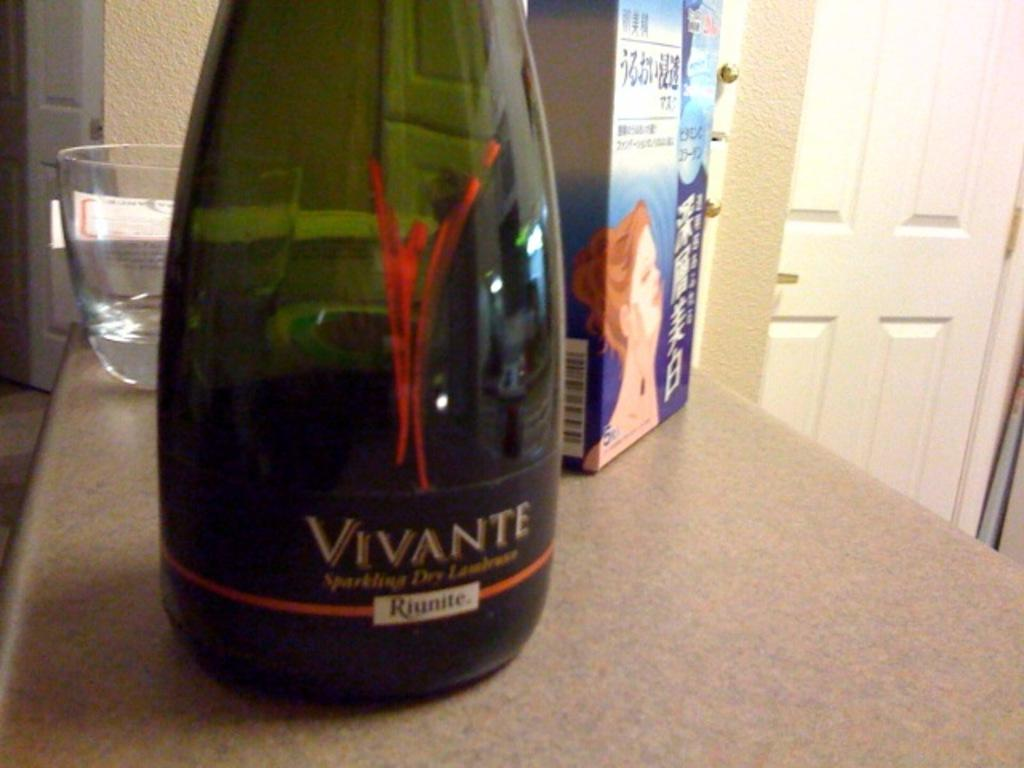Provide a one-sentence caption for the provided image. a bottle of Riunite vivante is istting on a table. 